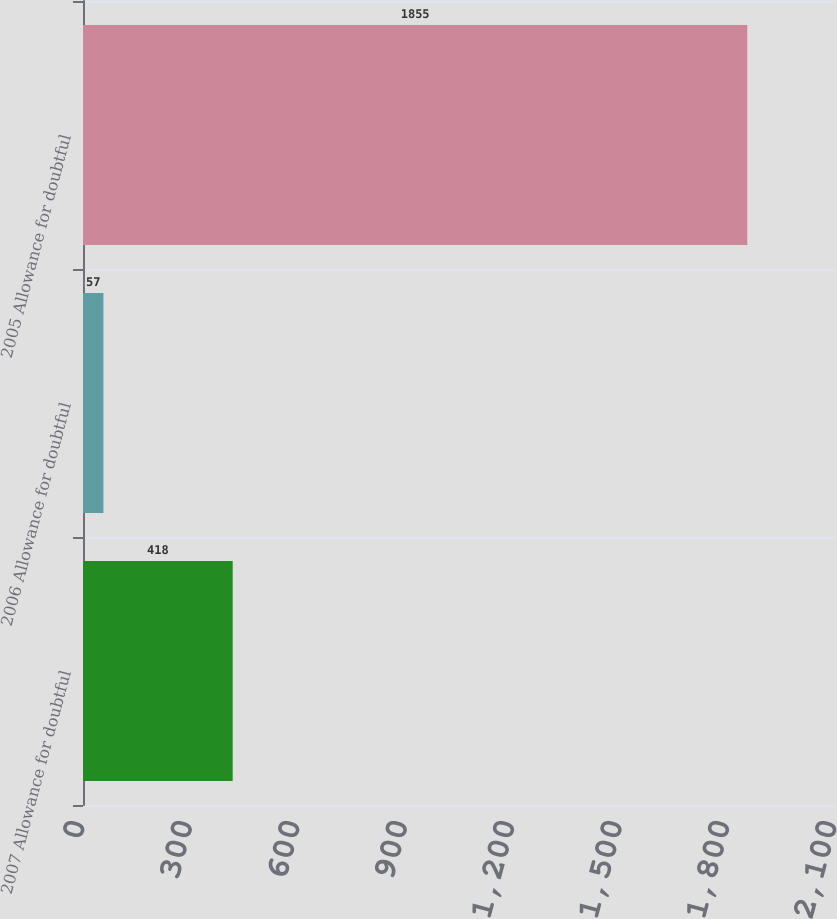Convert chart to OTSL. <chart><loc_0><loc_0><loc_500><loc_500><bar_chart><fcel>2007 Allowance for doubtful<fcel>2006 Allowance for doubtful<fcel>2005 Allowance for doubtful<nl><fcel>418<fcel>57<fcel>1855<nl></chart> 